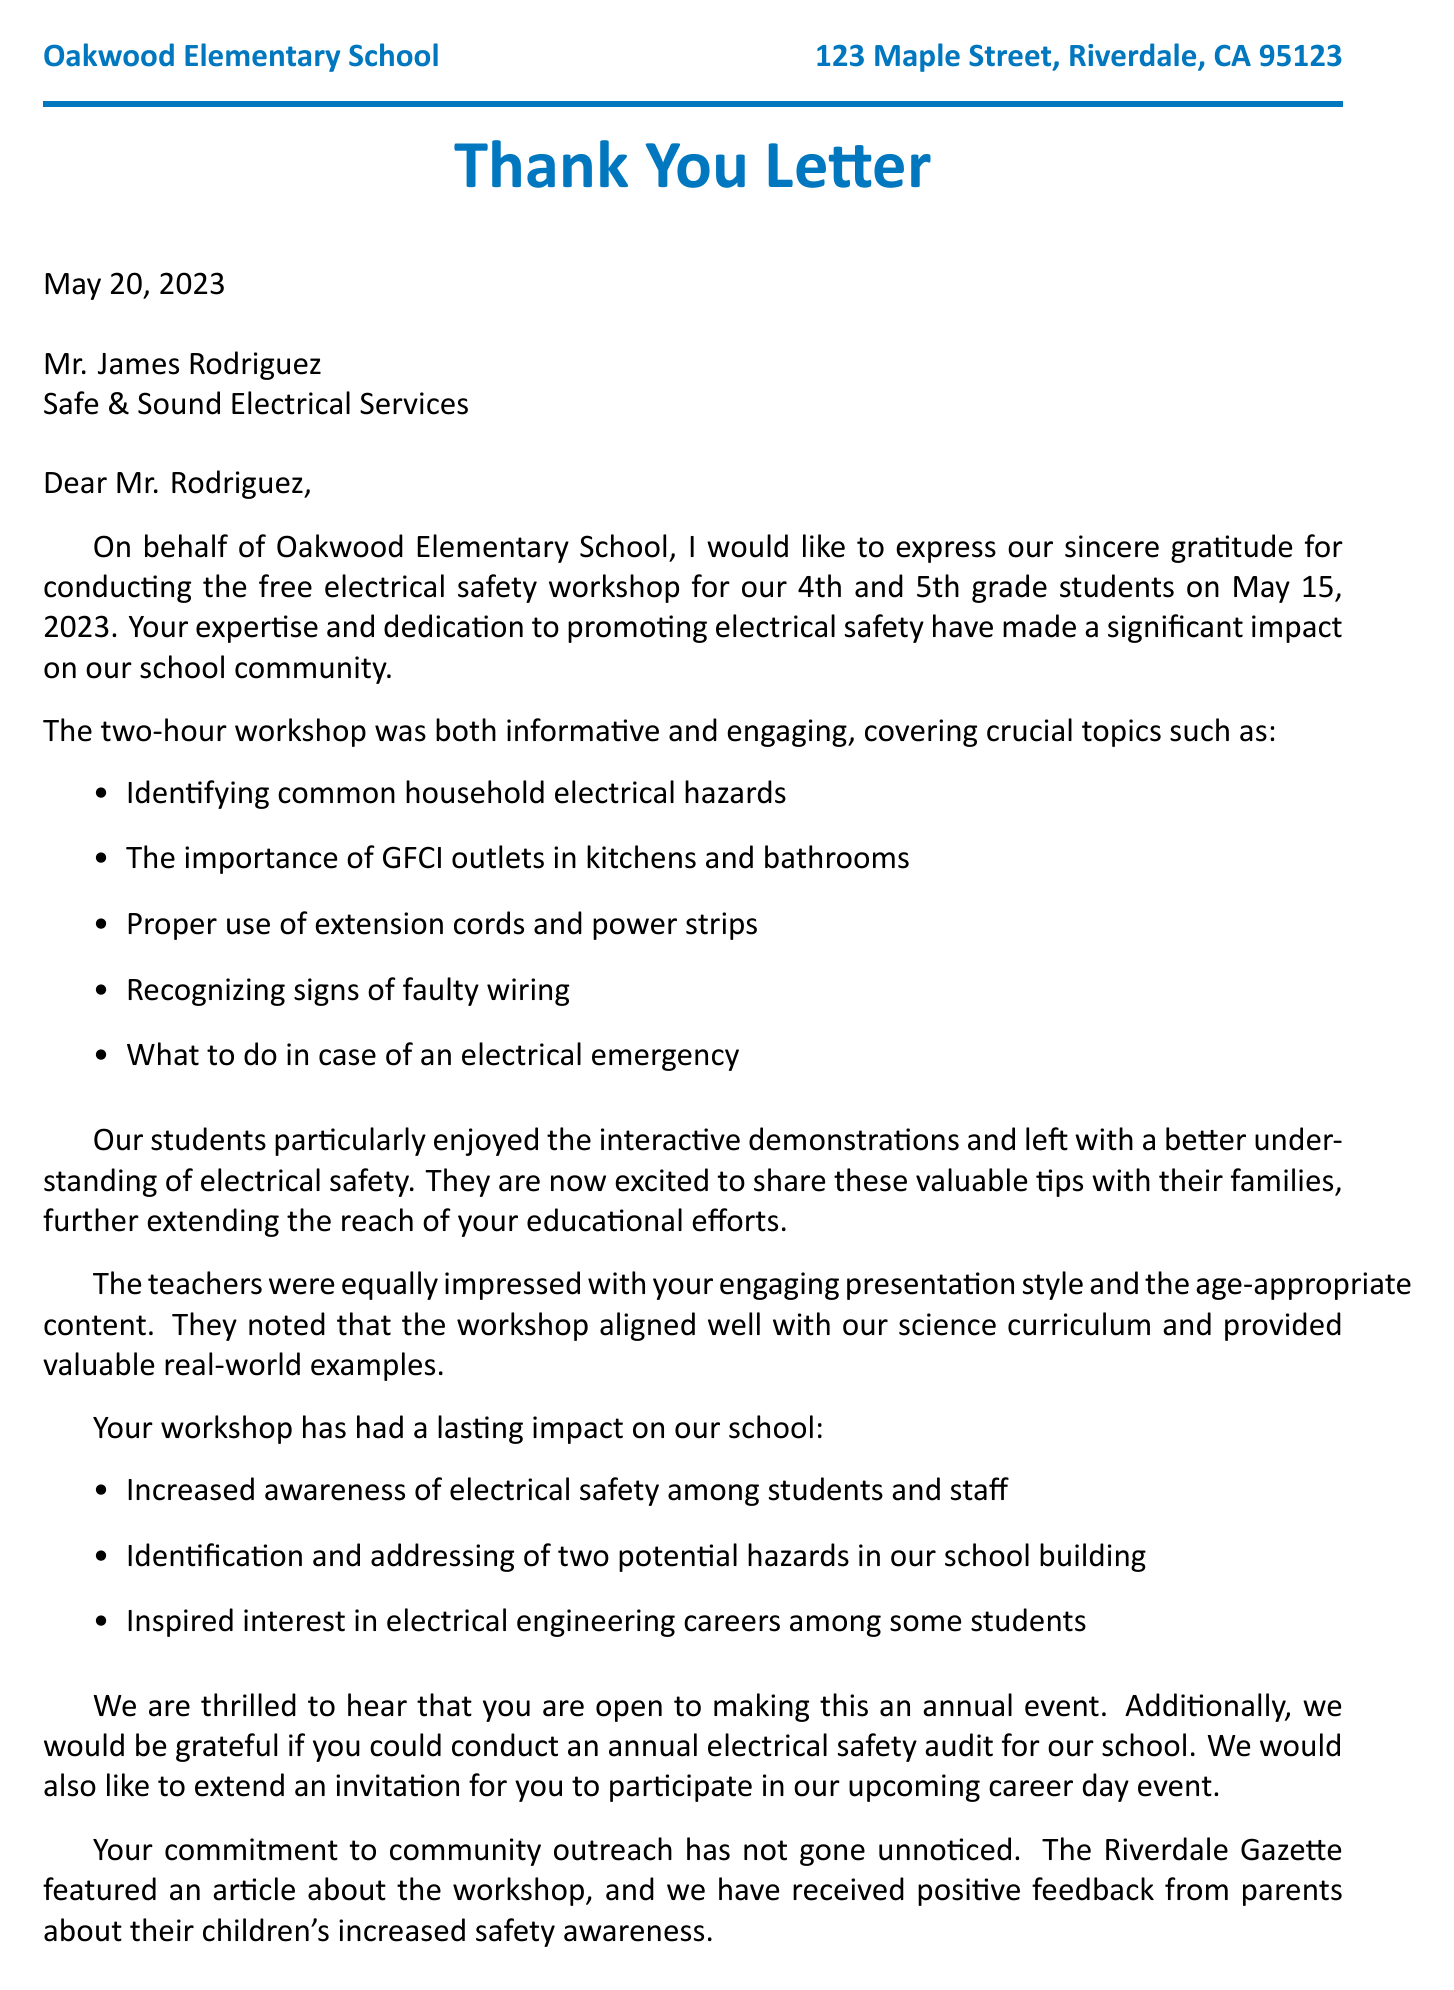What is the name of the school mentioned in the document? The school name is stated at the beginning of the document, identifying Oakwood Elementary School.
Answer: Oakwood Elementary School Who conducted the electrical safety workshop? The document specifies the individual's name who conducted the workshop, Mr. James Rodriguez.
Answer: Mr. James Rodriguez How long did the workshop last? The duration of the workshop is highlighted in the workshop details, noted as 2 hours.
Answer: 2 hours When was the workshop held? The date of the workshop is provided in the document, listed as May 15, 2023.
Answer: May 15, 2023 What is one topic covered in the workshop? The workshop covered multiple topics, one being the importance of GFCI outlets in kitchens and bathrooms.
Answer: The importance of GFCI outlets in kitchens and bathrooms How many students participated in the workshop? The document indicates that 75 students attended the workshop.
Answer: 75 What did teachers think of the workshop presentation? Feedback from teachers is included in the letter, stating they found the presentation style engaging.
Answer: Engaging presentation style What is one future collaboration mentioned? The document discusses an invitation for Mr. Rodriguez to participate in the career day event.
Answer: Career day event What impact did the workshop have on the school? One mentioned impact was the increased awareness of electrical safety among students and staff.
Answer: Increased awareness of electrical safety among students and staff 